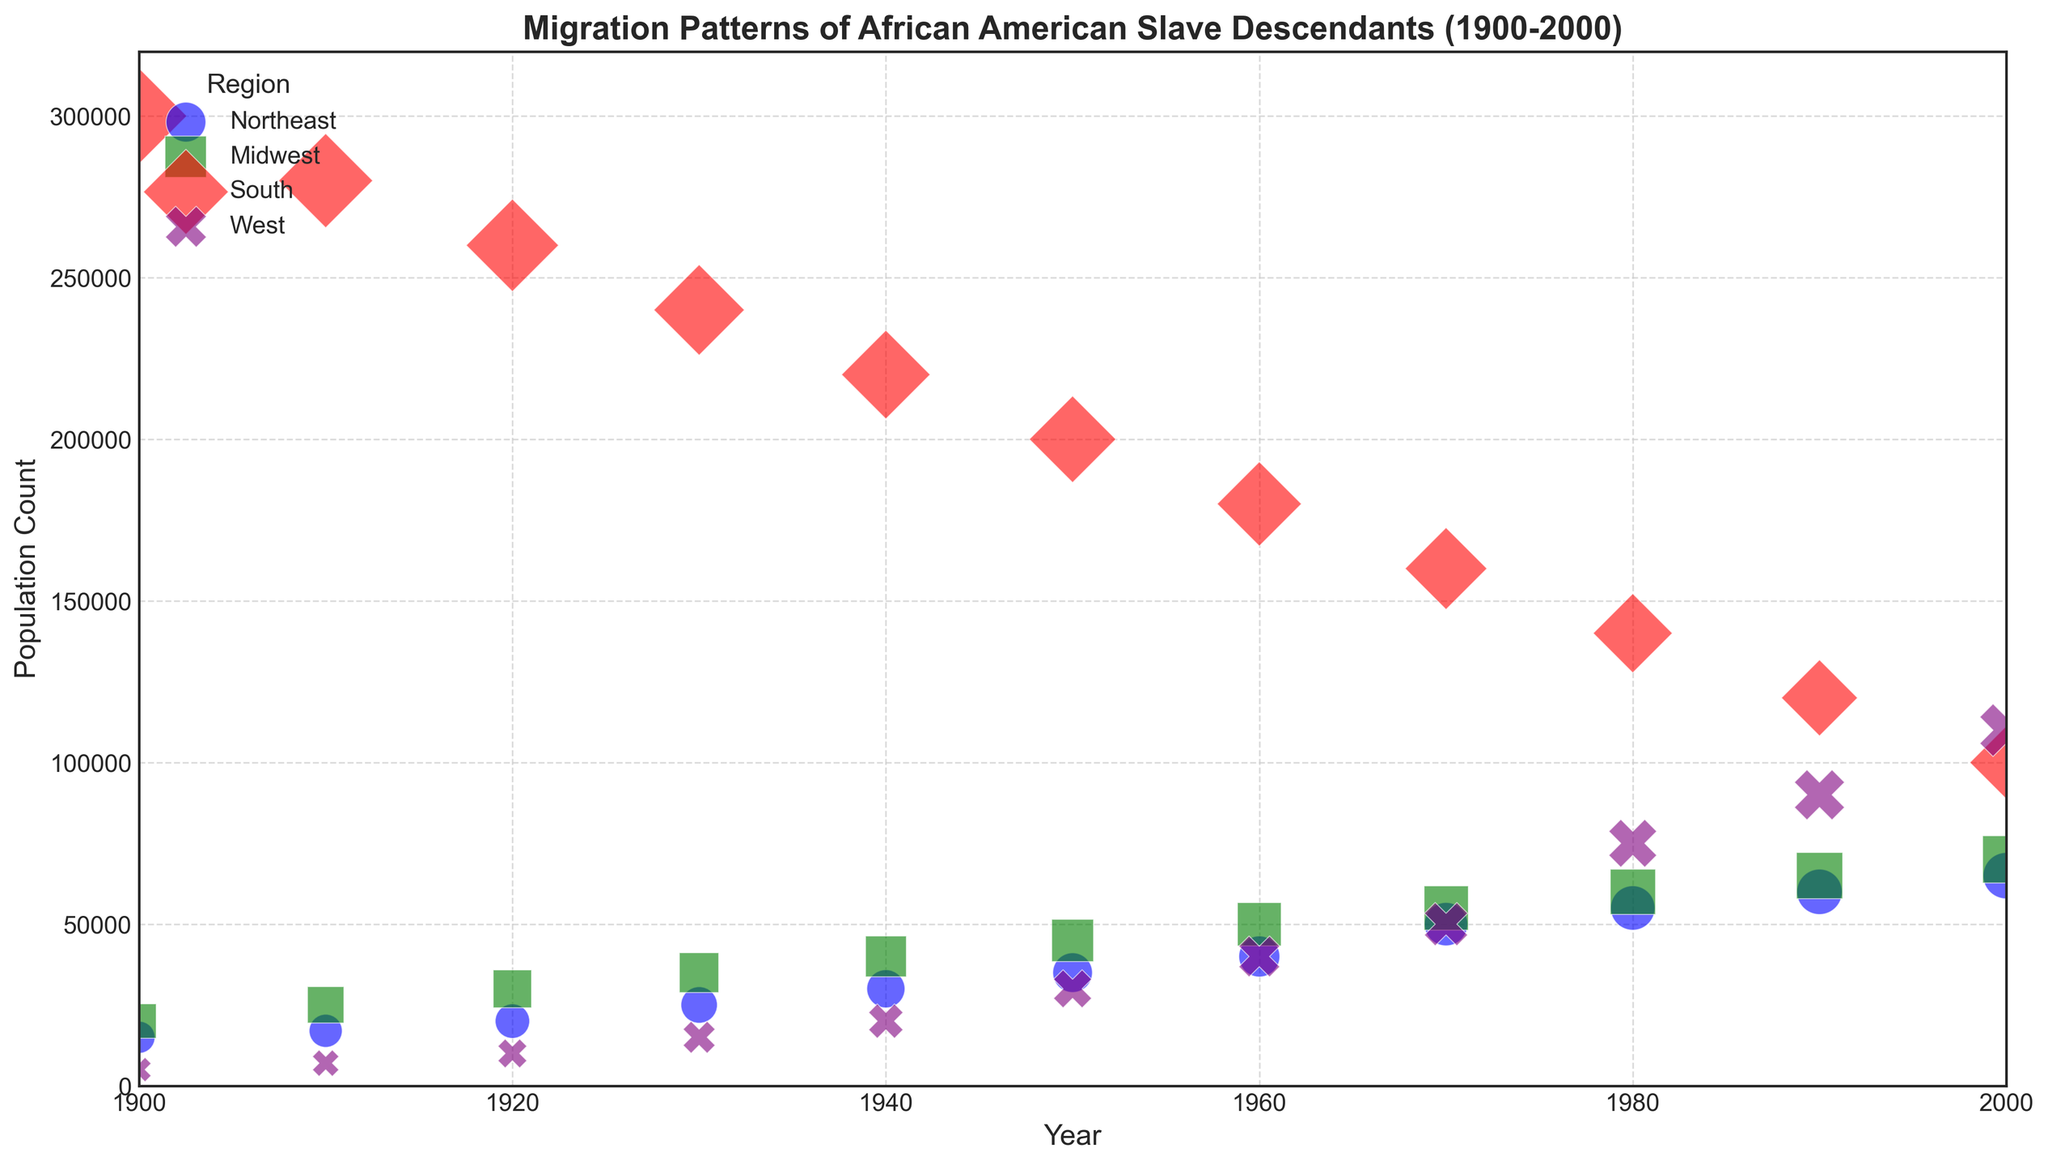Which region had the highest population count in 1900? By looking at the size of the bubbles for the year 1900, we can see the South has the largest bubble, indicating it had the highest population count.
Answer: South What is the overall trend in the population count for the Northeast region from 1900 to 2000? By observing the bubble sizes for the Northeast region over the years, we see a consistent increase in size, indicating a rising population trend.
Answer: Increasing Between which decades did the South see the most significant population decrease? By examining the bubble sizes for the South, the biggest reduction is between 1960 and 1970, where the bubble size noticeably decreased.
Answer: 1960 to 1970 How does the population trend in the West region compare to the South region from 1900 to 2000? While the West shows a consistent increase in bubble sizes (indicating population growth), the South shows a consistent decrease from 1900 to 2000.
Answer: West increasing, South decreasing By what year did the Midwest region's population count surpass 50,000? By observing the bubbles for the Midwest, the population count surpasses 50,000 between 1950 and 1960. Checking these years, it's clear it happened by 1960.
Answer: 1960 Which region had the smallest population count in 1920, and what was the approximate count? The smallest bubble in 1920 belongs to the West region. The count seen from the data is 10,000.
Answer: West, 10,000 Comparing the populations in 1940, which region had a larger population: the Midwest or the West? By looking at the bubble sizes for 1940, the Midwest bubble is larger than the West bubble, indicating a higher population.
Answer: Midwest During which decade did the population of the West region experience the most substantial growth? Observing the bubble sizes for the West region, the most noticeable increase occurs between 1940 and 1950.
Answer: 1940 to 1950 What percentage of the South region's population in 1900 had migrated to the Northeast by 2000? In 1900, the South had 300,000, and in 2000, the Northeast had 65,000. The percentage is (65,000 / 300,000) * 100%.
Answer: 21.67% In 1990, which region had a population closest to 60,000? Checking the bubble sizes for 1990, both the Northeast and Midwest have bubbles around 60,000, but technically, only the Northeast is exactly 60,000.
Answer: Northeast 